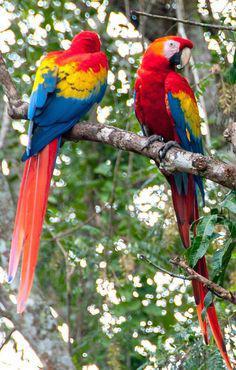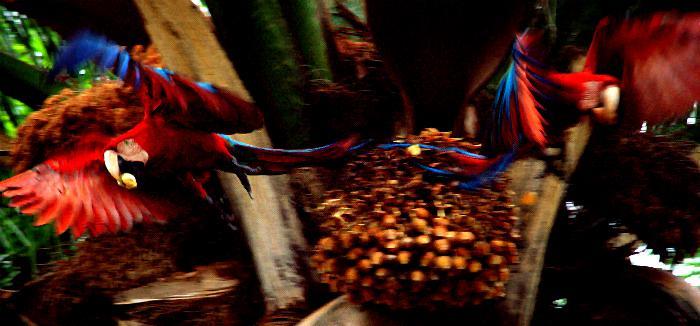The first image is the image on the left, the second image is the image on the right. Analyze the images presented: Is the assertion "The right image features at least six blue parrots." valid? Answer yes or no. No. 